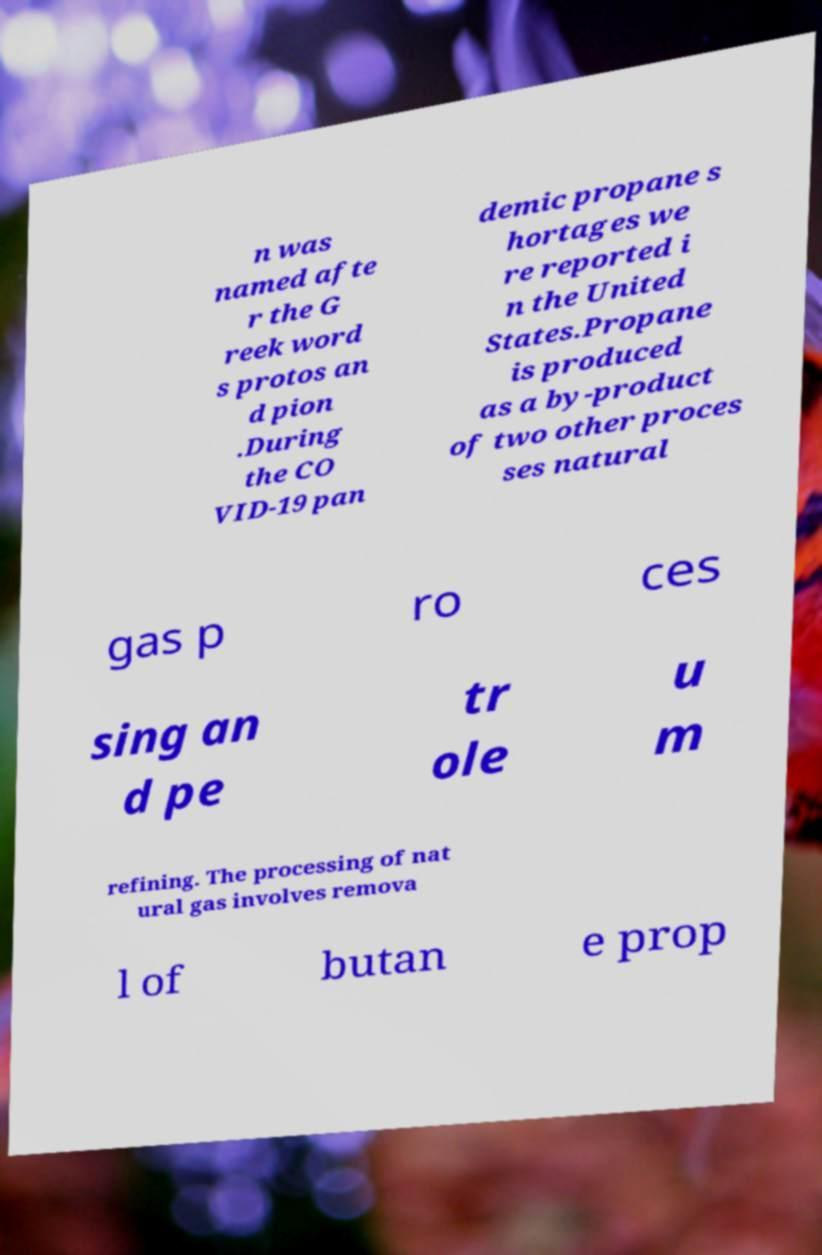For documentation purposes, I need the text within this image transcribed. Could you provide that? n was named afte r the G reek word s protos an d pion .During the CO VID-19 pan demic propane s hortages we re reported i n the United States.Propane is produced as a by-product of two other proces ses natural gas p ro ces sing an d pe tr ole u m refining. The processing of nat ural gas involves remova l of butan e prop 